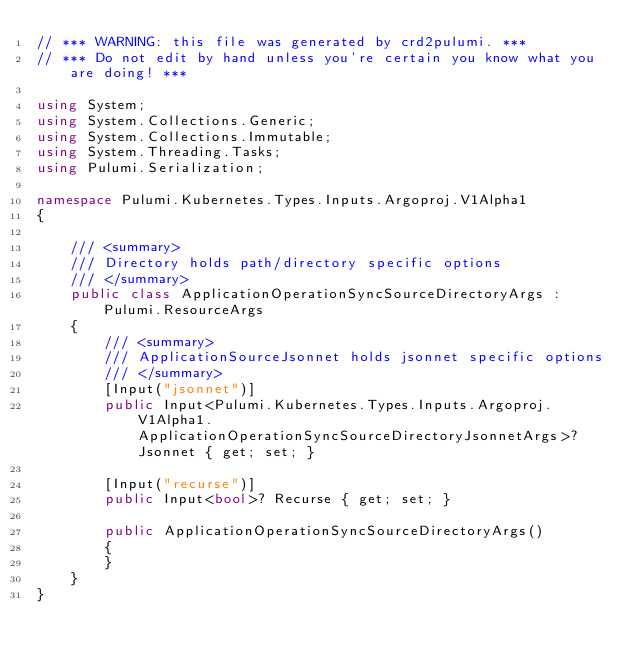Convert code to text. <code><loc_0><loc_0><loc_500><loc_500><_C#_>// *** WARNING: this file was generated by crd2pulumi. ***
// *** Do not edit by hand unless you're certain you know what you are doing! ***

using System;
using System.Collections.Generic;
using System.Collections.Immutable;
using System.Threading.Tasks;
using Pulumi.Serialization;

namespace Pulumi.Kubernetes.Types.Inputs.Argoproj.V1Alpha1
{

    /// <summary>
    /// Directory holds path/directory specific options
    /// </summary>
    public class ApplicationOperationSyncSourceDirectoryArgs : Pulumi.ResourceArgs
    {
        /// <summary>
        /// ApplicationSourceJsonnet holds jsonnet specific options
        /// </summary>
        [Input("jsonnet")]
        public Input<Pulumi.Kubernetes.Types.Inputs.Argoproj.V1Alpha1.ApplicationOperationSyncSourceDirectoryJsonnetArgs>? Jsonnet { get; set; }

        [Input("recurse")]
        public Input<bool>? Recurse { get; set; }

        public ApplicationOperationSyncSourceDirectoryArgs()
        {
        }
    }
}
</code> 